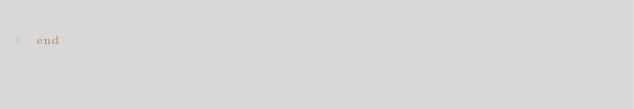<code> <loc_0><loc_0><loc_500><loc_500><_Ruby_>end
</code> 